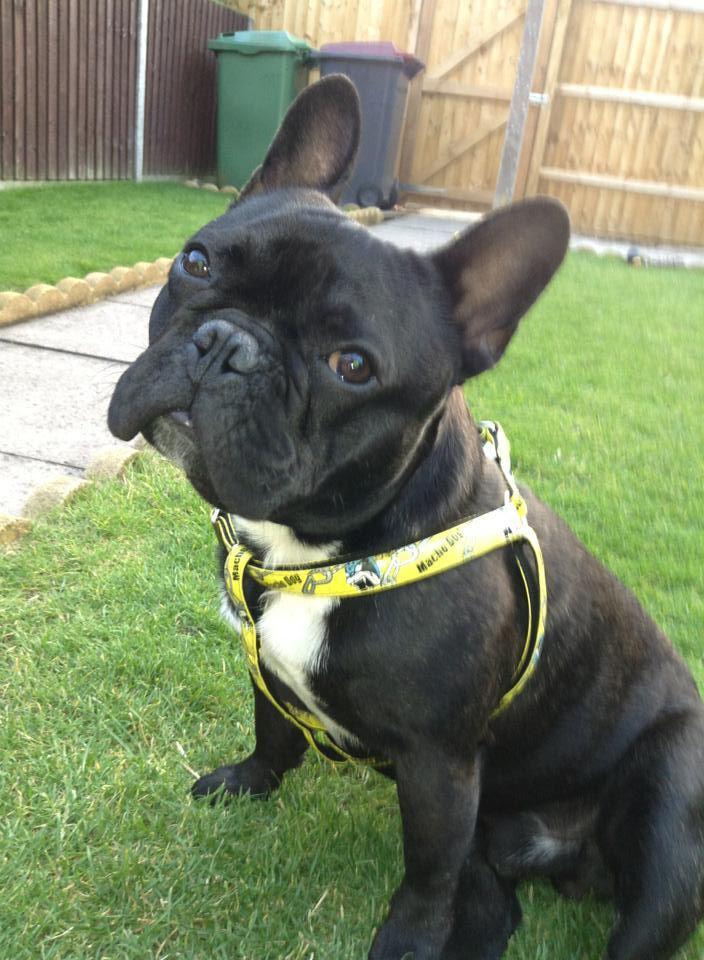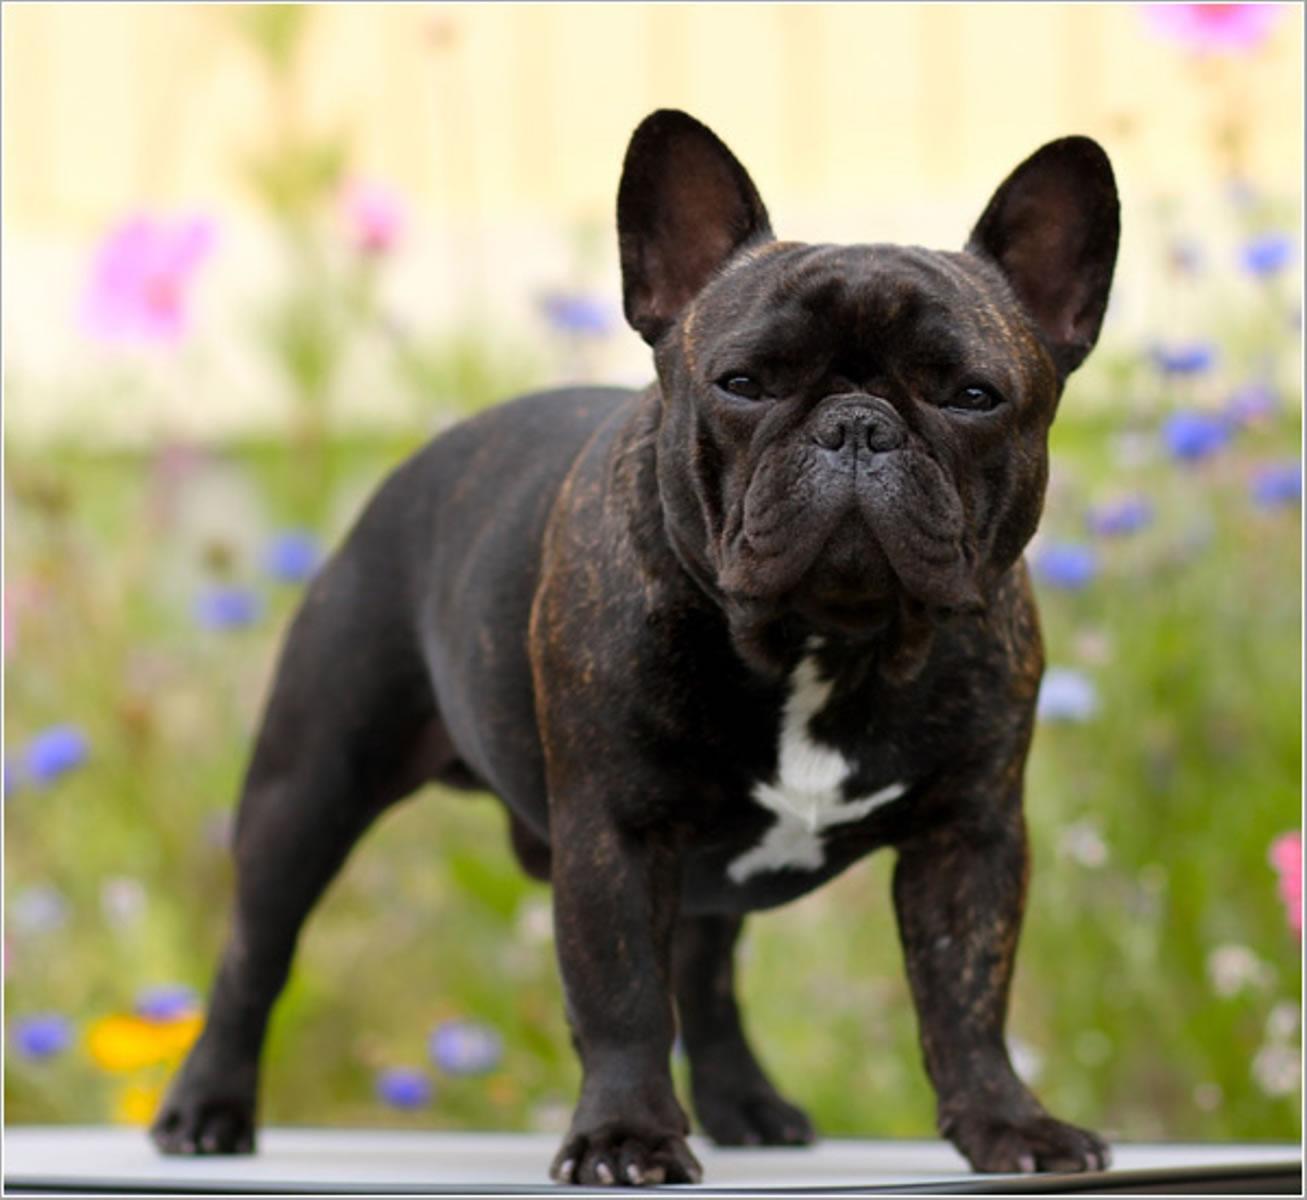The first image is the image on the left, the second image is the image on the right. Given the left and right images, does the statement "Each image contains a dark french bulldog in a sitting pose, and the dog in the left image has its body turned rightward while the dog on the right looks directly at the camera." hold true? Answer yes or no. No. The first image is the image on the left, the second image is the image on the right. For the images shown, is this caption "All the dogs are sitting." true? Answer yes or no. No. 